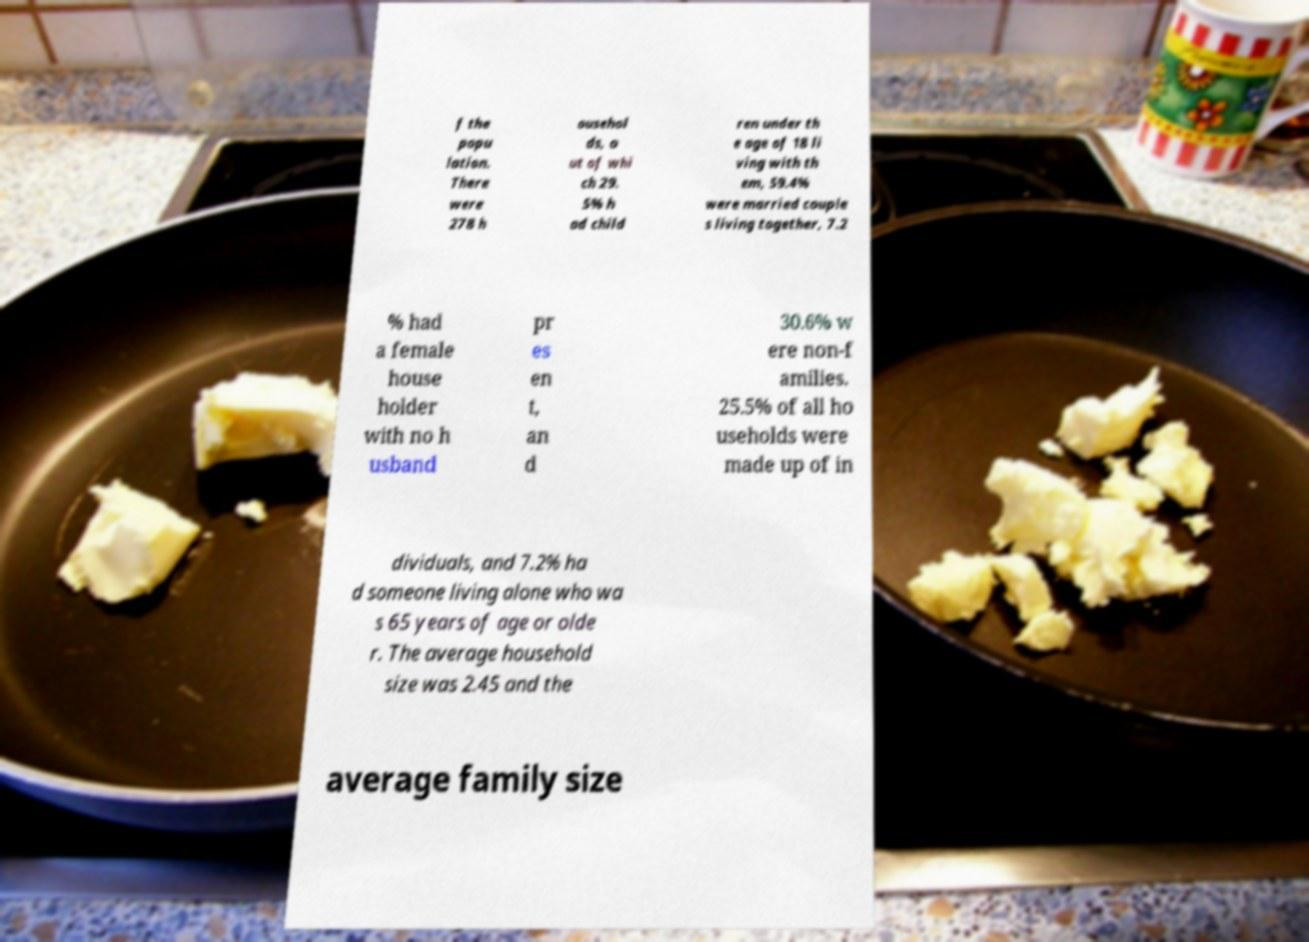I need the written content from this picture converted into text. Can you do that? f the popu lation. There were 278 h ousehol ds, o ut of whi ch 29. 5% h ad child ren under th e age of 18 li ving with th em, 59.4% were married couple s living together, 7.2 % had a female house holder with no h usband pr es en t, an d 30.6% w ere non-f amilies. 25.5% of all ho useholds were made up of in dividuals, and 7.2% ha d someone living alone who wa s 65 years of age or olde r. The average household size was 2.45 and the average family size 